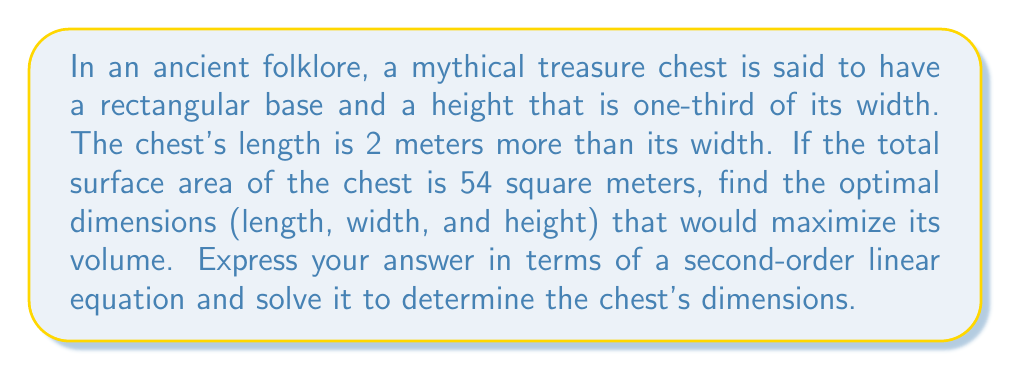Can you answer this question? Let's approach this step-by-step:

1) Let $w$ be the width of the chest. Then:
   - Length: $l = w + 2$
   - Height: $h = \frac{1}{3}w$

2) The surface area of a rectangular prism is given by:
   $SA = 2(lw + lh + wh)$

3) Substituting our expressions:
   $54 = 2[(w+2)w + (w+2)(\frac{1}{3}w) + w(\frac{1}{3}w)]$

4) Simplifying:
   $54 = 2[w^2 + 2w + \frac{1}{3}w^2 + \frac{2}{3}w + \frac{1}{3}w^2]$
   $54 = 2[\frac{5}{3}w^2 + \frac{8}{3}w]$
   $54 = \frac{10}{3}w^2 + \frac{16}{3}w$

5) Multiplying both sides by 3:
   $162 = 10w^2 + 16w$

6) Rearranging to standard form:
   $10w^2 + 16w - 162 = 0$

7) This is our second-order linear equation. We can solve it using the quadratic formula:
   $w = \frac{-b \pm \sqrt{b^2 - 4ac}}{2a}$

   Where $a=10$, $b=16$, and $c=-162$

8) Solving:
   $w = \frac{-16 \pm \sqrt{16^2 - 4(10)(-162)}}{2(10)}$
   $w = \frac{-16 \pm \sqrt{256 + 6480}}{20}$
   $w = \frac{-16 \pm \sqrt{6736}}{20}$
   $w = \frac{-16 \pm 82.07}{20}$

9) This gives us two solutions:
   $w = 3.30$ or $w = -4.90$

   Since width cannot be negative, we take $w = 3.30$ meters.

10) Now we can calculate the other dimensions:
    Length: $l = w + 2 = 3.30 + 2 = 5.30$ meters
    Height: $h = \frac{1}{3}w = \frac{1}{3}(3.30) = 1.10$ meters
Answer: The optimal dimensions of the mythical treasure chest that maximize its volume are:
Length: 5.30 meters
Width: 3.30 meters
Height: 1.10 meters 